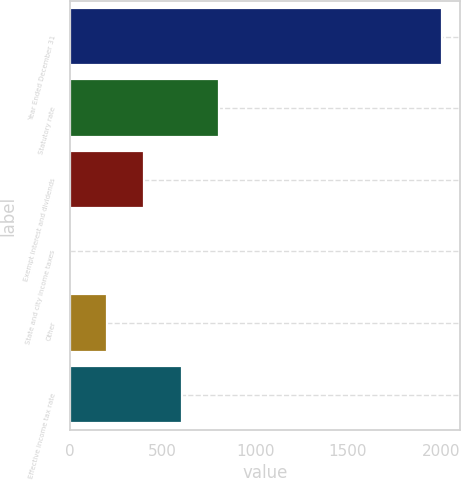Convert chart. <chart><loc_0><loc_0><loc_500><loc_500><bar_chart><fcel>Year Ended December 31<fcel>Statutory rate<fcel>Exempt interest and dividends<fcel>State and city income taxes<fcel>Other<fcel>Effective income tax rate<nl><fcel>2006<fcel>803<fcel>402<fcel>1<fcel>201.5<fcel>602.5<nl></chart> 